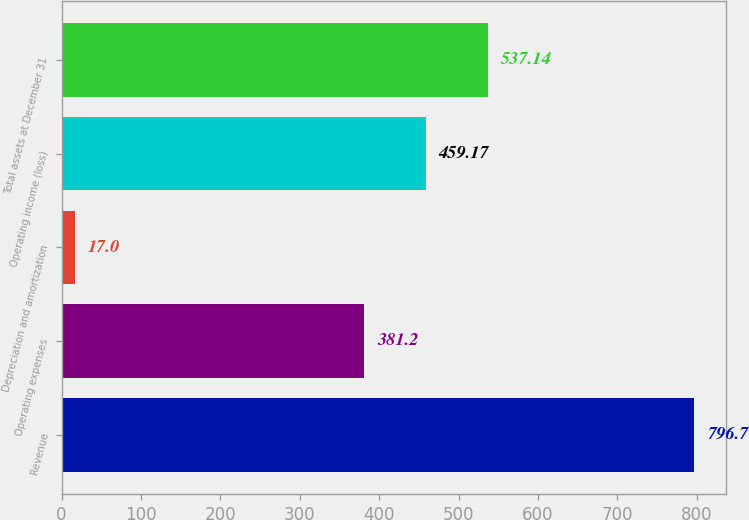<chart> <loc_0><loc_0><loc_500><loc_500><bar_chart><fcel>Revenue<fcel>Operating expenses<fcel>Depreciation and amortization<fcel>Operating income (loss)<fcel>Total assets at December 31<nl><fcel>796.7<fcel>381.2<fcel>17<fcel>459.17<fcel>537.14<nl></chart> 